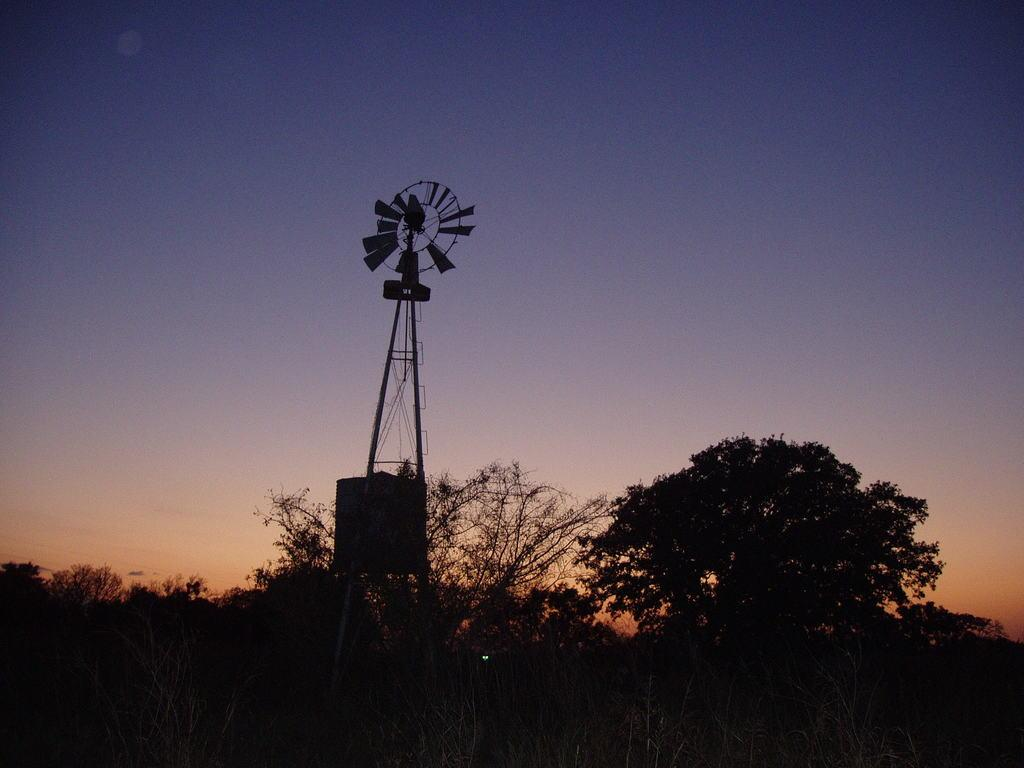What is the main structure in the image? There is a windmill in the image. How is the windmill positioned in the image? The windmill is placed on the ground. What can be seen in the background of the image? There is a group of trees and the sky visible in the background of the image. What type of marble is used to construct the windmill in the image? There is no mention of marble in the image, as the windmill is likely constructed using more traditional materials like wood or metal. 